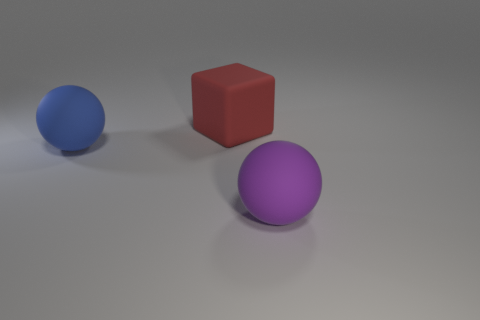What could be the purpose of this image? This image could serve several purposes. It might be a simple rendering test to showcase modeling and lighting skills, a visual aid for a discussion about geometry and colors, or an element in a larger conceptual art piece commenting on form and space. 